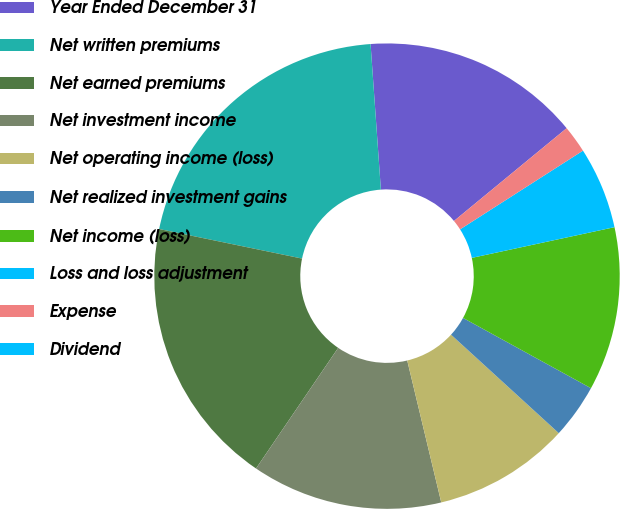Convert chart to OTSL. <chart><loc_0><loc_0><loc_500><loc_500><pie_chart><fcel>Year Ended December 31<fcel>Net written premiums<fcel>Net earned premiums<fcel>Net investment income<fcel>Net operating income (loss)<fcel>Net realized investment gains<fcel>Net income (loss)<fcel>Loss and loss adjustment<fcel>Expense<fcel>Dividend<nl><fcel>15.16%<fcel>20.63%<fcel>18.73%<fcel>13.26%<fcel>9.47%<fcel>3.79%<fcel>11.37%<fcel>5.69%<fcel>1.9%<fcel>0.0%<nl></chart> 